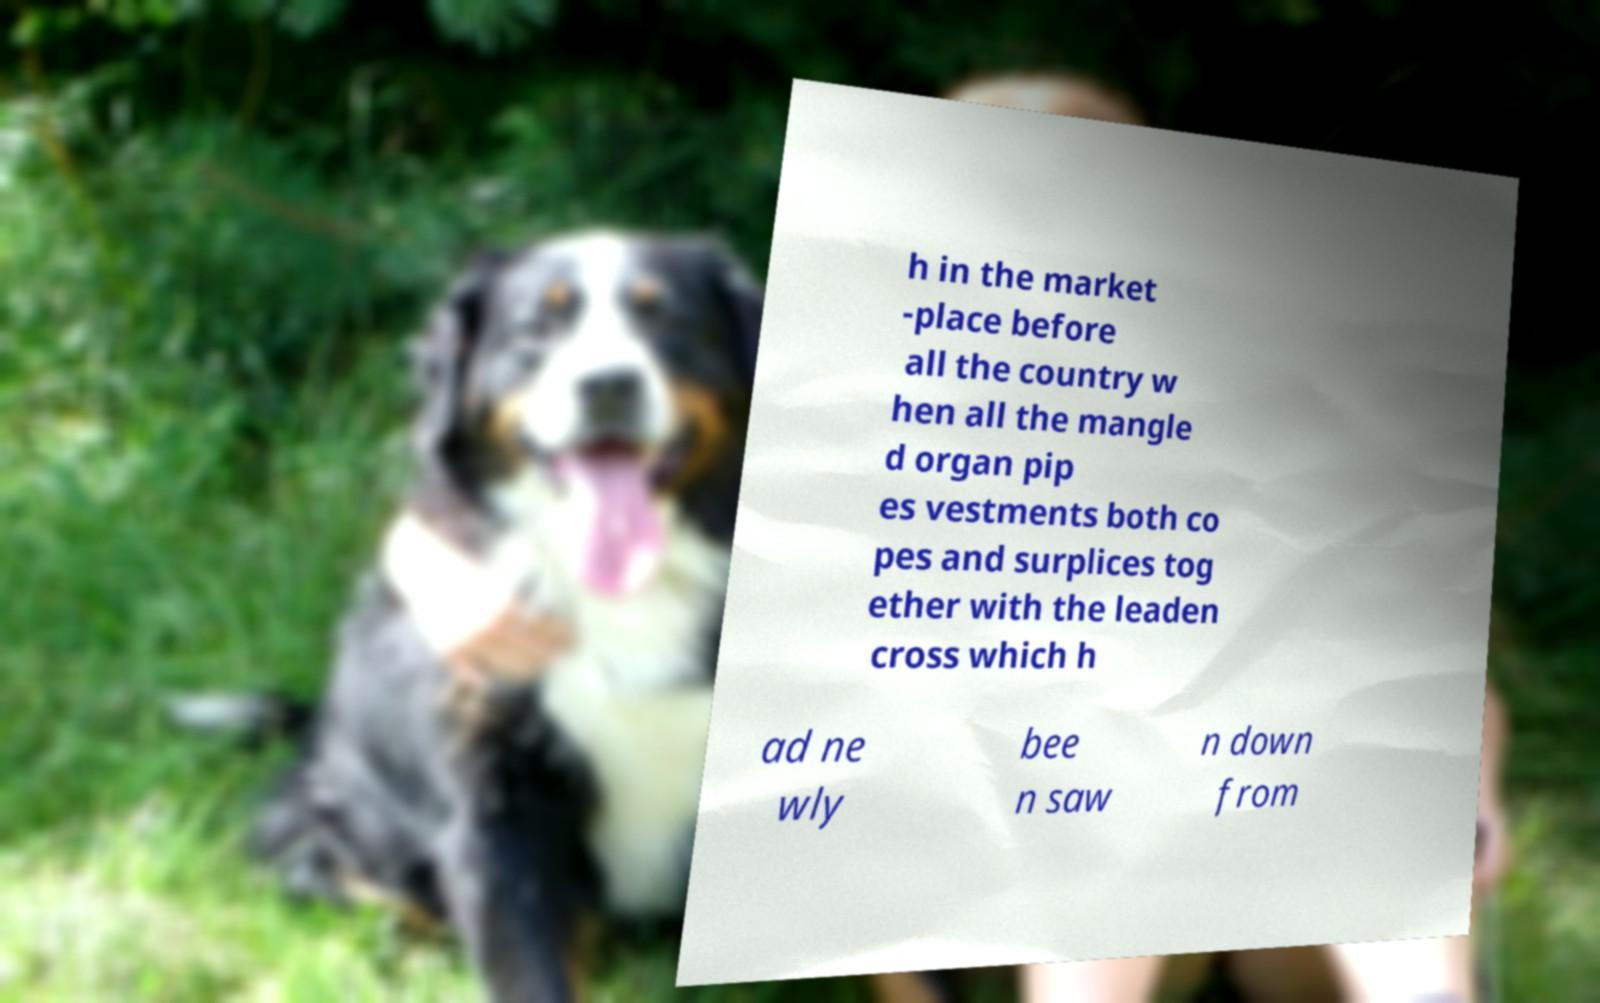Could you assist in decoding the text presented in this image and type it out clearly? h in the market -place before all the country w hen all the mangle d organ pip es vestments both co pes and surplices tog ether with the leaden cross which h ad ne wly bee n saw n down from 